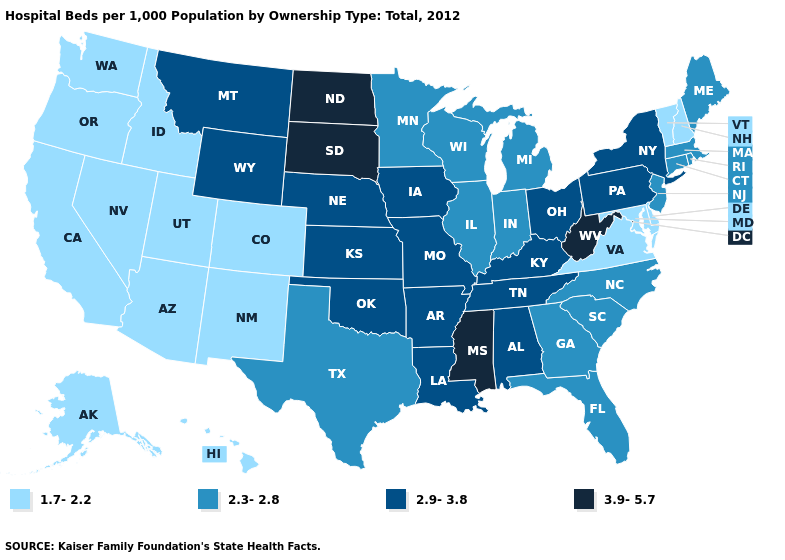What is the value of South Carolina?
Short answer required. 2.3-2.8. Does New Mexico have the lowest value in the USA?
Answer briefly. Yes. Which states hav the highest value in the MidWest?
Short answer required. North Dakota, South Dakota. Does Montana have a higher value than Kentucky?
Be succinct. No. What is the value of South Carolina?
Write a very short answer. 2.3-2.8. Which states have the lowest value in the Northeast?
Give a very brief answer. New Hampshire, Vermont. Which states have the lowest value in the USA?
Be succinct. Alaska, Arizona, California, Colorado, Delaware, Hawaii, Idaho, Maryland, Nevada, New Hampshire, New Mexico, Oregon, Utah, Vermont, Virginia, Washington. What is the value of Indiana?
Be succinct. 2.3-2.8. Does Virginia have a lower value than Ohio?
Concise answer only. Yes. What is the value of New Jersey?
Keep it brief. 2.3-2.8. Does Oregon have the same value as Colorado?
Keep it brief. Yes. What is the value of New Hampshire?
Short answer required. 1.7-2.2. Which states have the highest value in the USA?
Answer briefly. Mississippi, North Dakota, South Dakota, West Virginia. Name the states that have a value in the range 3.9-5.7?
Keep it brief. Mississippi, North Dakota, South Dakota, West Virginia. 